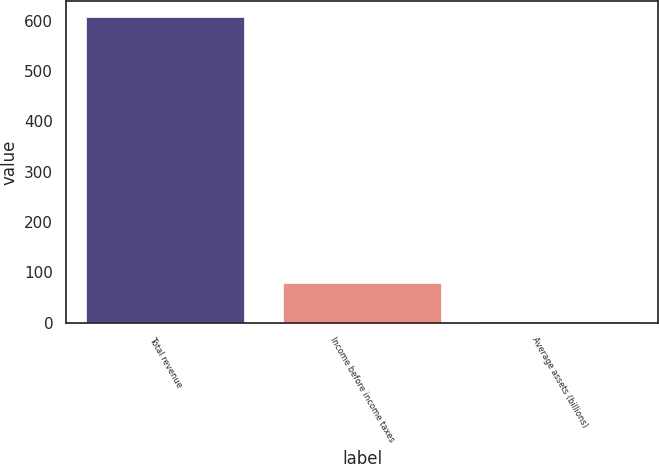Convert chart. <chart><loc_0><loc_0><loc_500><loc_500><bar_chart><fcel>Total revenue<fcel>Income before income taxes<fcel>Average assets (billions)<nl><fcel>608<fcel>78<fcel>1.8<nl></chart> 